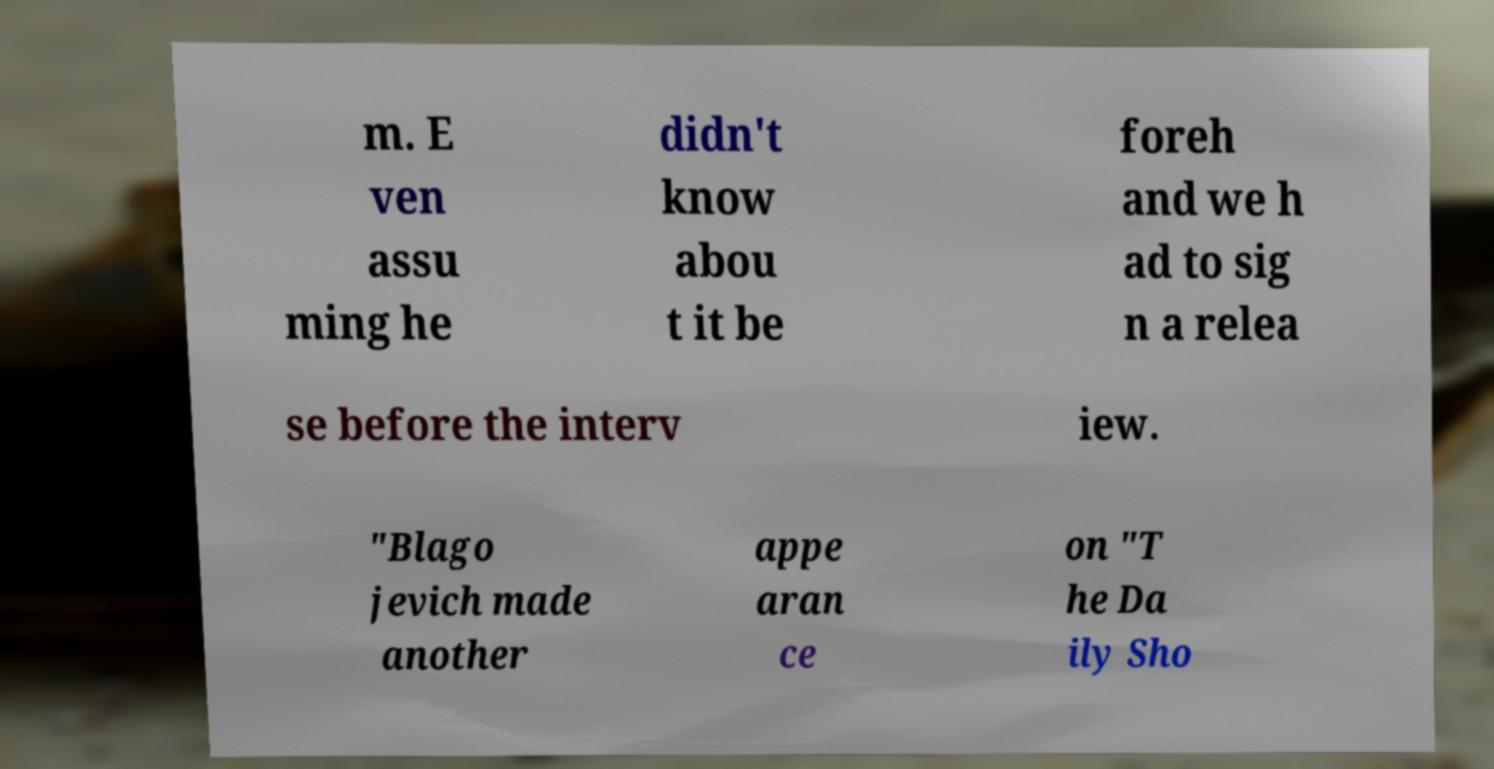Can you accurately transcribe the text from the provided image for me? m. E ven assu ming he didn't know abou t it be foreh and we h ad to sig n a relea se before the interv iew. "Blago jevich made another appe aran ce on "T he Da ily Sho 